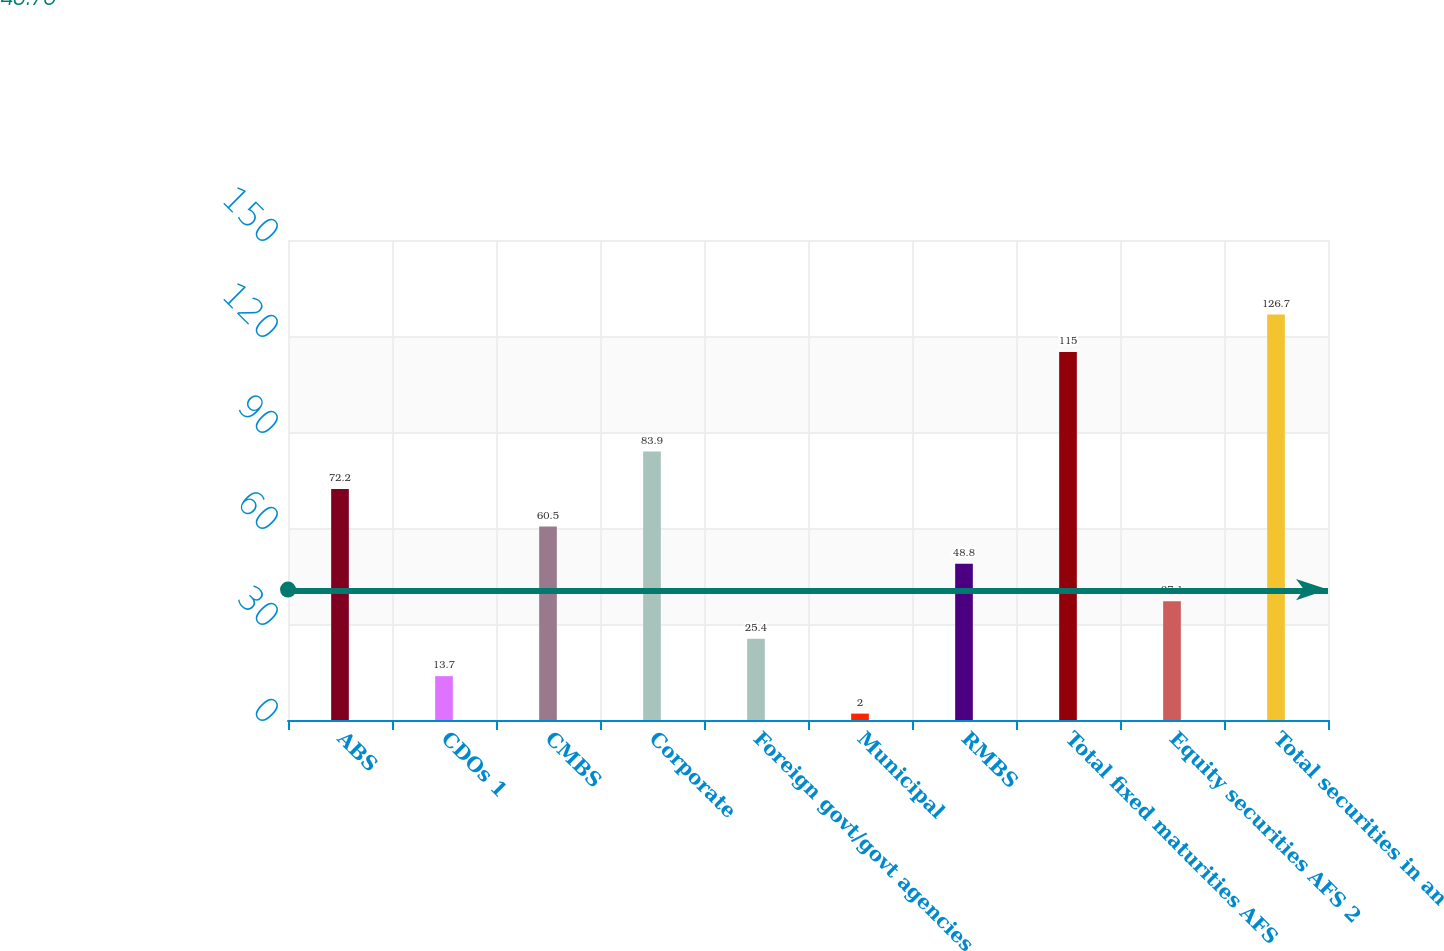Convert chart to OTSL. <chart><loc_0><loc_0><loc_500><loc_500><bar_chart><fcel>ABS<fcel>CDOs 1<fcel>CMBS<fcel>Corporate<fcel>Foreign govt/govt agencies<fcel>Municipal<fcel>RMBS<fcel>Total fixed maturities AFS<fcel>Equity securities AFS 2<fcel>Total securities in an<nl><fcel>72.2<fcel>13.7<fcel>60.5<fcel>83.9<fcel>25.4<fcel>2<fcel>48.8<fcel>115<fcel>37.1<fcel>126.7<nl></chart> 